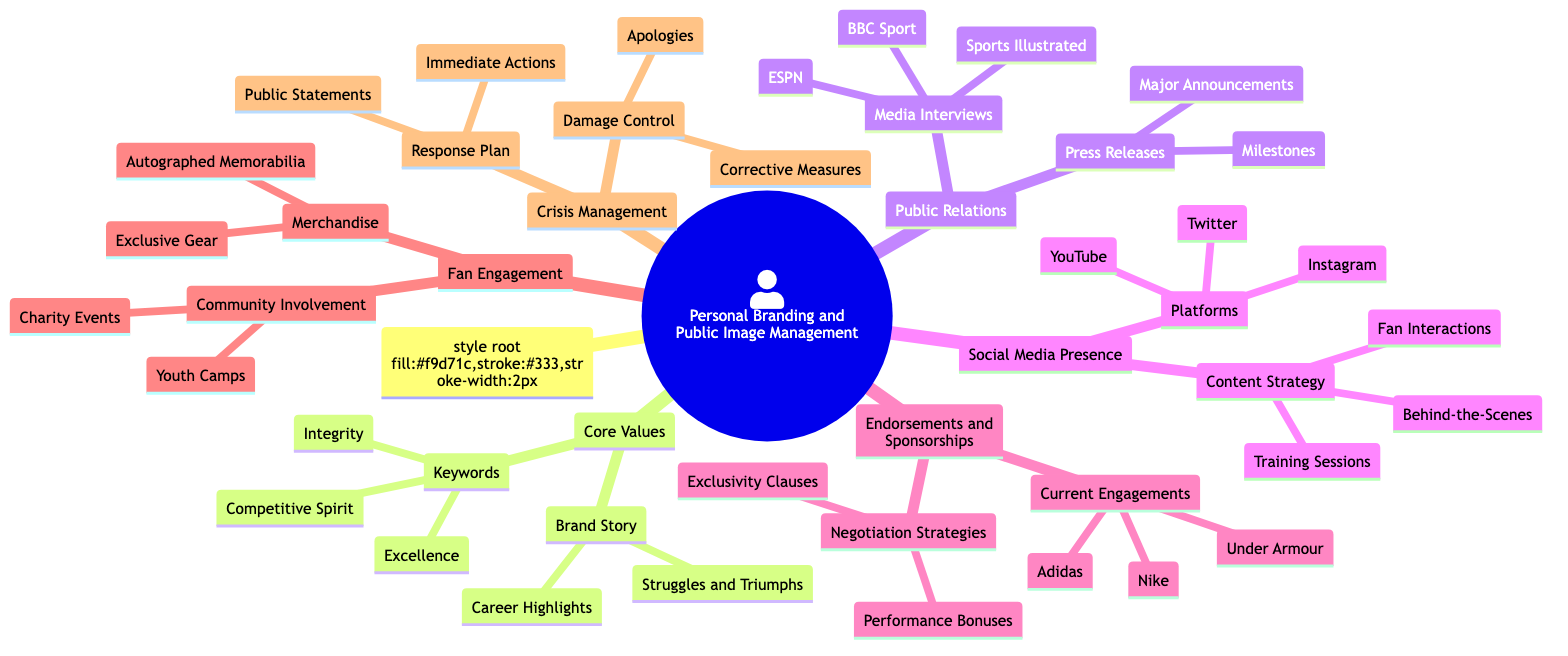What are the core values listed in the diagram? The Core Values node contains three keywords: Integrity, Excellence, and Competitive Spirit. These are specified directly under the Core Values category.
Answer: Integrity, Excellence, Competitive Spirit How many media interview platforms are mentioned? The Media Interviews node includes three platforms: Sports Illustrated, ESPN, and BBC Sport. Counting these gives a total of three media platforms.
Answer: 3 Which endorsement company is not listed under Current Engagements? The Current Engagements node specifies three companies: Nike, Adidas, and Under Armour. Any company not mentioned there, such as Puma, is not listed.
Answer: Puma What is one of the elements included in the Crisis Management section? Within the Crisis Management category, there are two main nodes: Response Plan and Damage Control. One specific element could be either Immediate Actions or Apologies.
Answer: Immediate Actions How many content strategies are outlined for Social Media Presence? The Content Strategy node has three elements: Behind-the-Scenes, Training Sessions, and Fan Interactions. Thus, there are three content strategies outlined.
Answer: 3 Which endorsement negotiation strategy is mentioned? The Negotiation Strategies node includes two strategies: Exclusivity Clauses and Performance Bonuses. Therefore, one mentioned strategy would be either of them.
Answer: Exclusivity Clauses What is listed under Community Involvement? The Community Involvement node consists of two activities: Charity Events and Youth Camps. One of these could be provided as an answer.
Answer: Charity Events Which keyword represents a core value related to performance? The three keywords under Core Values are Integrity, Excellence, and Competitive Spirit. Among these, Competitive Spirit specifically relates to performance.
Answer: Competitive Spirit 